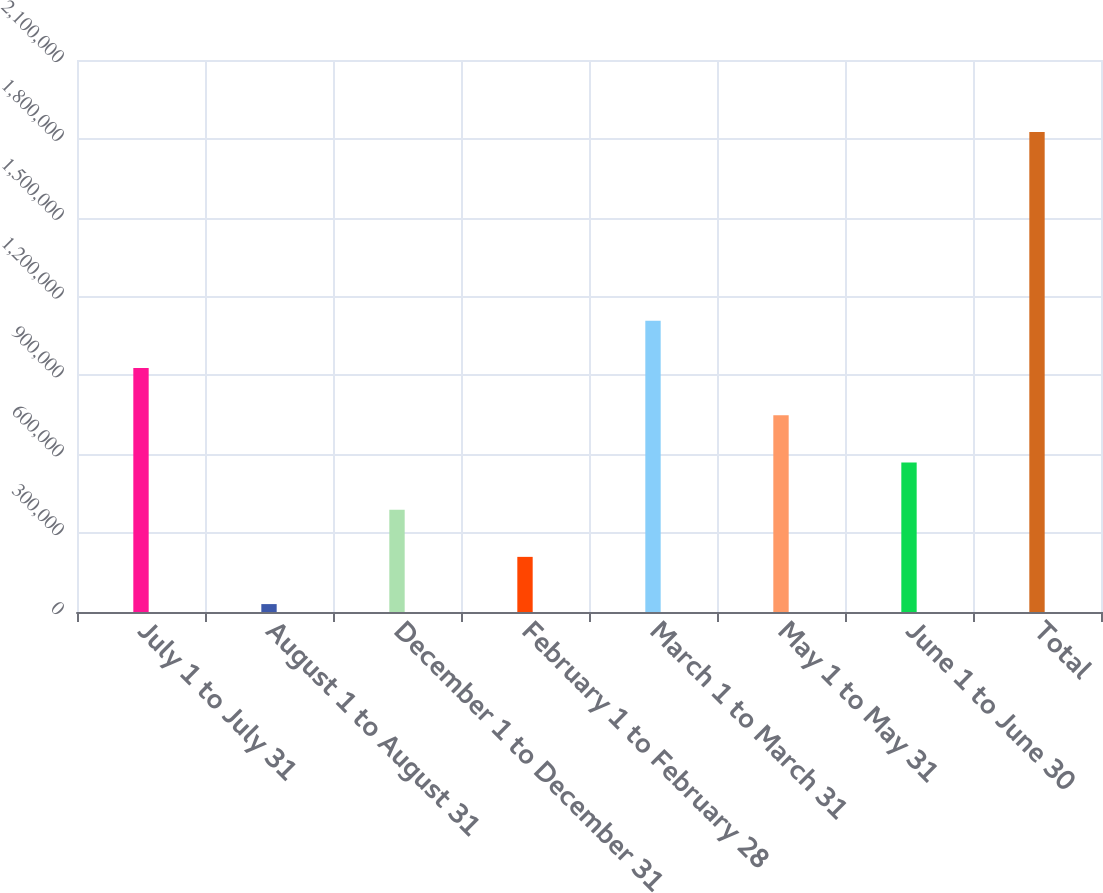Convert chart to OTSL. <chart><loc_0><loc_0><loc_500><loc_500><bar_chart><fcel>July 1 to July 31<fcel>August 1 to August 31<fcel>December 1 to December 31<fcel>February 1 to February 28<fcel>March 1 to March 31<fcel>May 1 to May 31<fcel>June 1 to June 30<fcel>Total<nl><fcel>928204<fcel>30100<fcel>389341<fcel>209721<fcel>1.10782e+06<fcel>748583<fcel>568962<fcel>1.82631e+06<nl></chart> 